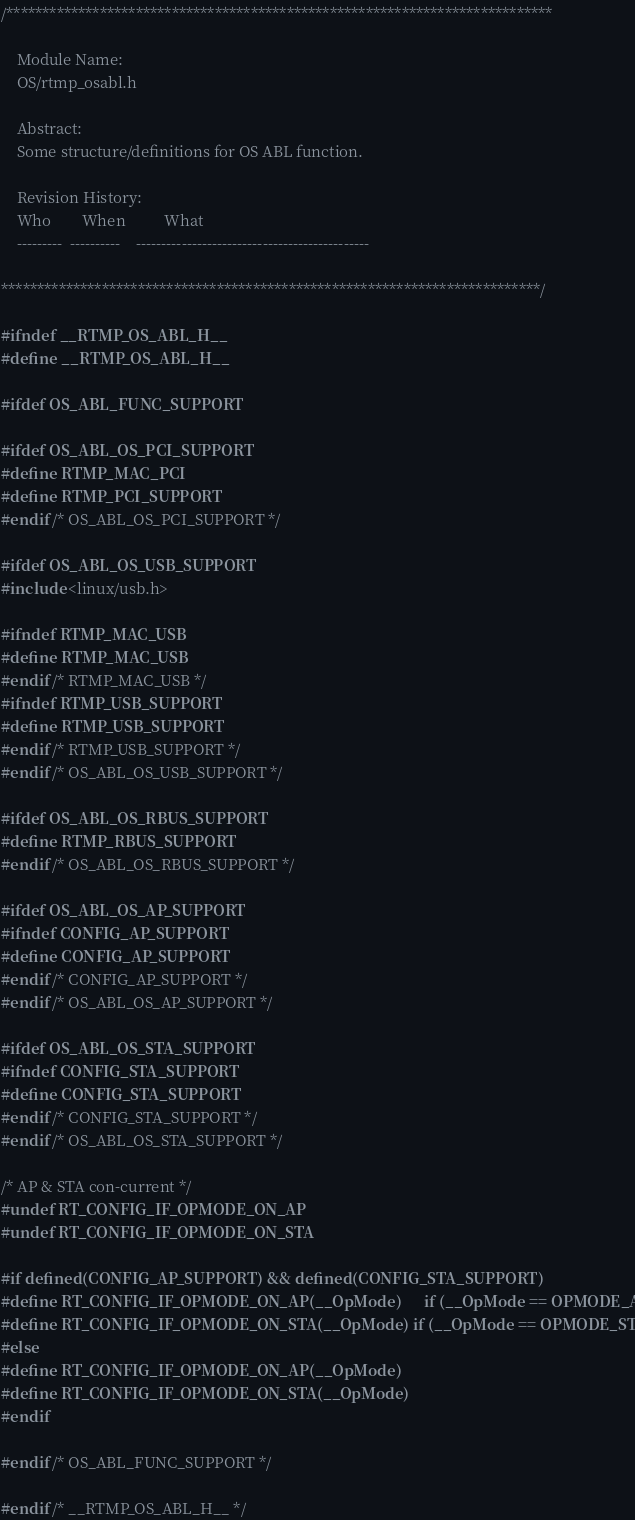<code> <loc_0><loc_0><loc_500><loc_500><_C_>/****************************************************************************

    Module Name:
    OS/rtmp_osabl.h
 
    Abstract:
	Some structure/definitions for OS ABL function.
 
    Revision History:
    Who        When          What
    ---------  ----------    ----------------------------------------------

***************************************************************************/

#ifndef __RTMP_OS_ABL_H__
#define __RTMP_OS_ABL_H__

#ifdef OS_ABL_FUNC_SUPPORT

#ifdef OS_ABL_OS_PCI_SUPPORT
#define RTMP_MAC_PCI
#define RTMP_PCI_SUPPORT
#endif /* OS_ABL_OS_PCI_SUPPORT */

#ifdef OS_ABL_OS_USB_SUPPORT
#include <linux/usb.h>

#ifndef RTMP_MAC_USB
#define RTMP_MAC_USB
#endif /* RTMP_MAC_USB */
#ifndef RTMP_USB_SUPPORT
#define RTMP_USB_SUPPORT
#endif /* RTMP_USB_SUPPORT */
#endif /* OS_ABL_OS_USB_SUPPORT */

#ifdef OS_ABL_OS_RBUS_SUPPORT
#define RTMP_RBUS_SUPPORT
#endif /* OS_ABL_OS_RBUS_SUPPORT */

#ifdef OS_ABL_OS_AP_SUPPORT
#ifndef CONFIG_AP_SUPPORT
#define CONFIG_AP_SUPPORT
#endif /* CONFIG_AP_SUPPORT */
#endif /* OS_ABL_OS_AP_SUPPORT */

#ifdef OS_ABL_OS_STA_SUPPORT
#ifndef CONFIG_STA_SUPPORT
#define CONFIG_STA_SUPPORT
#endif /* CONFIG_STA_SUPPORT */
#endif /* OS_ABL_OS_STA_SUPPORT */

/* AP & STA con-current */
#undef RT_CONFIG_IF_OPMODE_ON_AP
#undef RT_CONFIG_IF_OPMODE_ON_STA

#if defined(CONFIG_AP_SUPPORT) && defined(CONFIG_STA_SUPPORT)
#define RT_CONFIG_IF_OPMODE_ON_AP(__OpMode)		if (__OpMode == OPMODE_AP)
#define RT_CONFIG_IF_OPMODE_ON_STA(__OpMode)	if (__OpMode == OPMODE_STA)
#else
#define RT_CONFIG_IF_OPMODE_ON_AP(__OpMode)
#define RT_CONFIG_IF_OPMODE_ON_STA(__OpMode)
#endif

#endif /* OS_ABL_FUNC_SUPPORT */

#endif /* __RTMP_OS_ABL_H__ */

</code> 